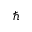Convert formula to latex. <formula><loc_0><loc_0><loc_500><loc_500>\hslash</formula> 